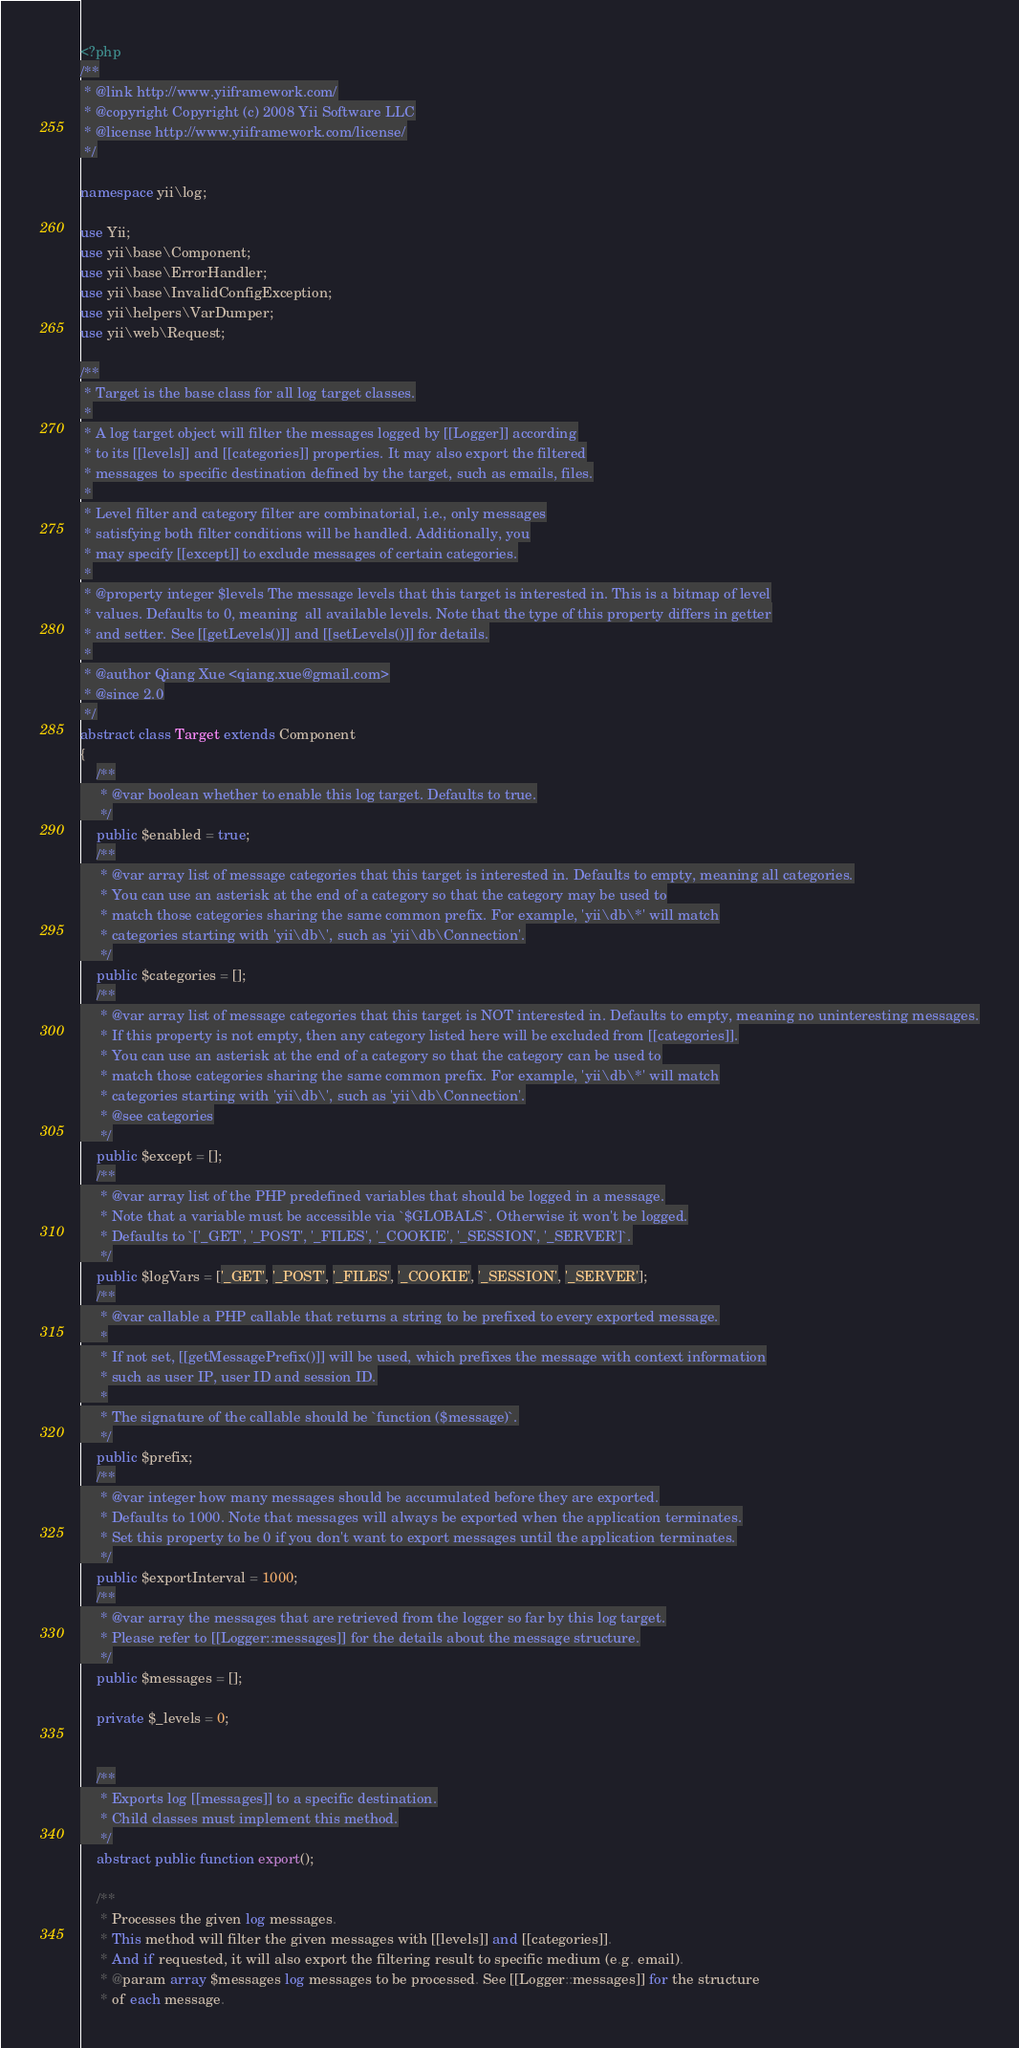Convert code to text. <code><loc_0><loc_0><loc_500><loc_500><_PHP_><?php
/**
 * @link http://www.yiiframework.com/
 * @copyright Copyright (c) 2008 Yii Software LLC
 * @license http://www.yiiframework.com/license/
 */

namespace yii\log;

use Yii;
use yii\base\Component;
use yii\base\ErrorHandler;
use yii\base\InvalidConfigException;
use yii\helpers\VarDumper;
use yii\web\Request;

/**
 * Target is the base class for all log target classes.
 *
 * A log target object will filter the messages logged by [[Logger]] according
 * to its [[levels]] and [[categories]] properties. It may also export the filtered
 * messages to specific destination defined by the target, such as emails, files.
 *
 * Level filter and category filter are combinatorial, i.e., only messages
 * satisfying both filter conditions will be handled. Additionally, you
 * may specify [[except]] to exclude messages of certain categories.
 *
 * @property integer $levels The message levels that this target is interested in. This is a bitmap of level
 * values. Defaults to 0, meaning  all available levels. Note that the type of this property differs in getter
 * and setter. See [[getLevels()]] and [[setLevels()]] for details.
 *
 * @author Qiang Xue <qiang.xue@gmail.com>
 * @since 2.0
 */
abstract class Target extends Component
{
    /**
     * @var boolean whether to enable this log target. Defaults to true.
     */
    public $enabled = true;
    /**
     * @var array list of message categories that this target is interested in. Defaults to empty, meaning all categories.
     * You can use an asterisk at the end of a category so that the category may be used to
     * match those categories sharing the same common prefix. For example, 'yii\db\*' will match
     * categories starting with 'yii\db\', such as 'yii\db\Connection'.
     */
    public $categories = [];
    /**
     * @var array list of message categories that this target is NOT interested in. Defaults to empty, meaning no uninteresting messages.
     * If this property is not empty, then any category listed here will be excluded from [[categories]].
     * You can use an asterisk at the end of a category so that the category can be used to
     * match those categories sharing the same common prefix. For example, 'yii\db\*' will match
     * categories starting with 'yii\db\', such as 'yii\db\Connection'.
     * @see categories
     */
    public $except = [];
    /**
     * @var array list of the PHP predefined variables that should be logged in a message.
     * Note that a variable must be accessible via `$GLOBALS`. Otherwise it won't be logged.
     * Defaults to `['_GET', '_POST', '_FILES', '_COOKIE', '_SESSION', '_SERVER']`.
     */
    public $logVars = ['_GET', '_POST', '_FILES', '_COOKIE', '_SESSION', '_SERVER'];
    /**
     * @var callable a PHP callable that returns a string to be prefixed to every exported message.
     *
     * If not set, [[getMessagePrefix()]] will be used, which prefixes the message with context information
     * such as user IP, user ID and session ID.
     *
     * The signature of the callable should be `function ($message)`.
     */
    public $prefix;
    /**
     * @var integer how many messages should be accumulated before they are exported.
     * Defaults to 1000. Note that messages will always be exported when the application terminates.
     * Set this property to be 0 if you don't want to export messages until the application terminates.
     */
    public $exportInterval = 1000;
    /**
     * @var array the messages that are retrieved from the logger so far by this log target.
     * Please refer to [[Logger::messages]] for the details about the message structure.
     */
    public $messages = [];

    private $_levels = 0;


    /**
     * Exports log [[messages]] to a specific destination.
     * Child classes must implement this method.
     */
    abstract public function export();

    /**
     * Processes the given log messages.
     * This method will filter the given messages with [[levels]] and [[categories]].
     * And if requested, it will also export the filtering result to specific medium (e.g. email).
     * @param array $messages log messages to be processed. See [[Logger::messages]] for the structure
     * of each message.</code> 